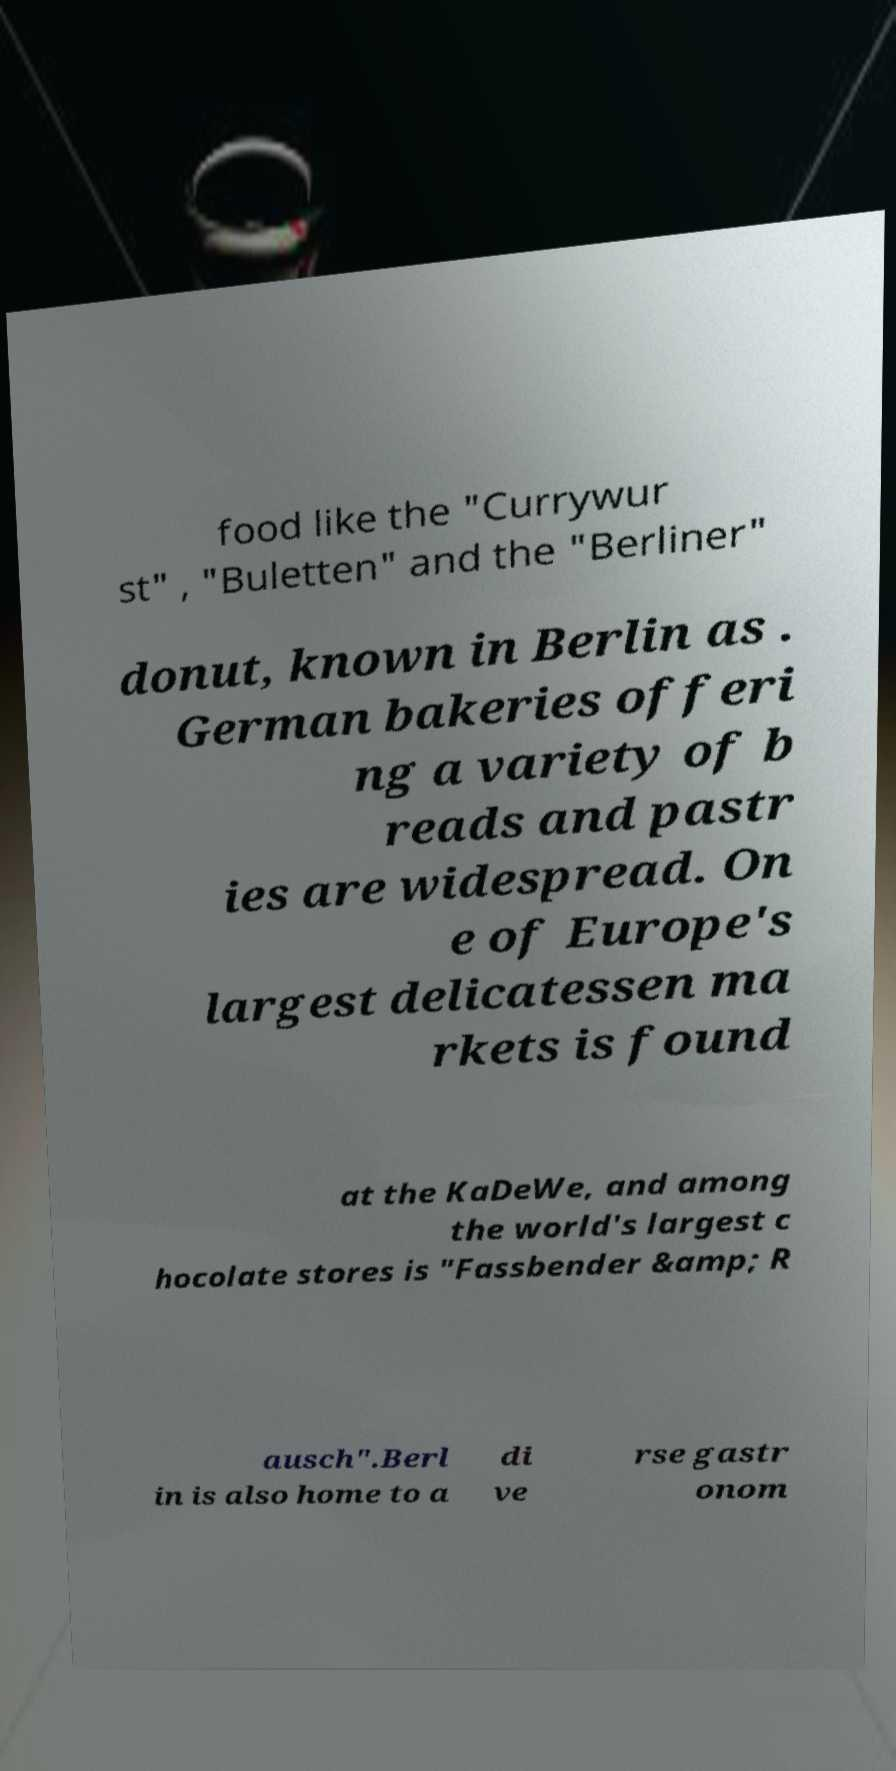Could you extract and type out the text from this image? food like the "Currywur st" , "Buletten" and the "Berliner" donut, known in Berlin as . German bakeries offeri ng a variety of b reads and pastr ies are widespread. On e of Europe's largest delicatessen ma rkets is found at the KaDeWe, and among the world's largest c hocolate stores is "Fassbender &amp; R ausch".Berl in is also home to a di ve rse gastr onom 